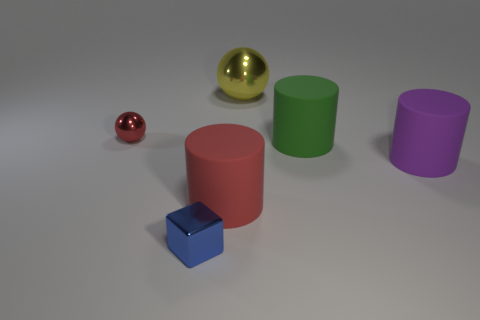Subtract all blocks. How many objects are left? 5 Subtract 1 spheres. How many spheres are left? 1 Subtract all green cylinders. How many cylinders are left? 2 Subtract 0 brown blocks. How many objects are left? 6 Subtract all cyan cubes. Subtract all yellow balls. How many cubes are left? 1 Subtract all blue cylinders. How many yellow balls are left? 1 Subtract all large matte cylinders. Subtract all red rubber cylinders. How many objects are left? 2 Add 6 purple rubber objects. How many purple rubber objects are left? 7 Add 1 blue blocks. How many blue blocks exist? 2 Add 4 small green matte cylinders. How many objects exist? 10 